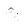<formula> <loc_0><loc_0><loc_500><loc_500>\hat { n } _ { i }</formula> 